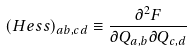<formula> <loc_0><loc_0><loc_500><loc_500>( H e s s ) _ { a b , c d } \equiv \frac { \partial ^ { 2 } F } { \partial Q _ { a , b } \partial Q _ { c , d } }</formula> 